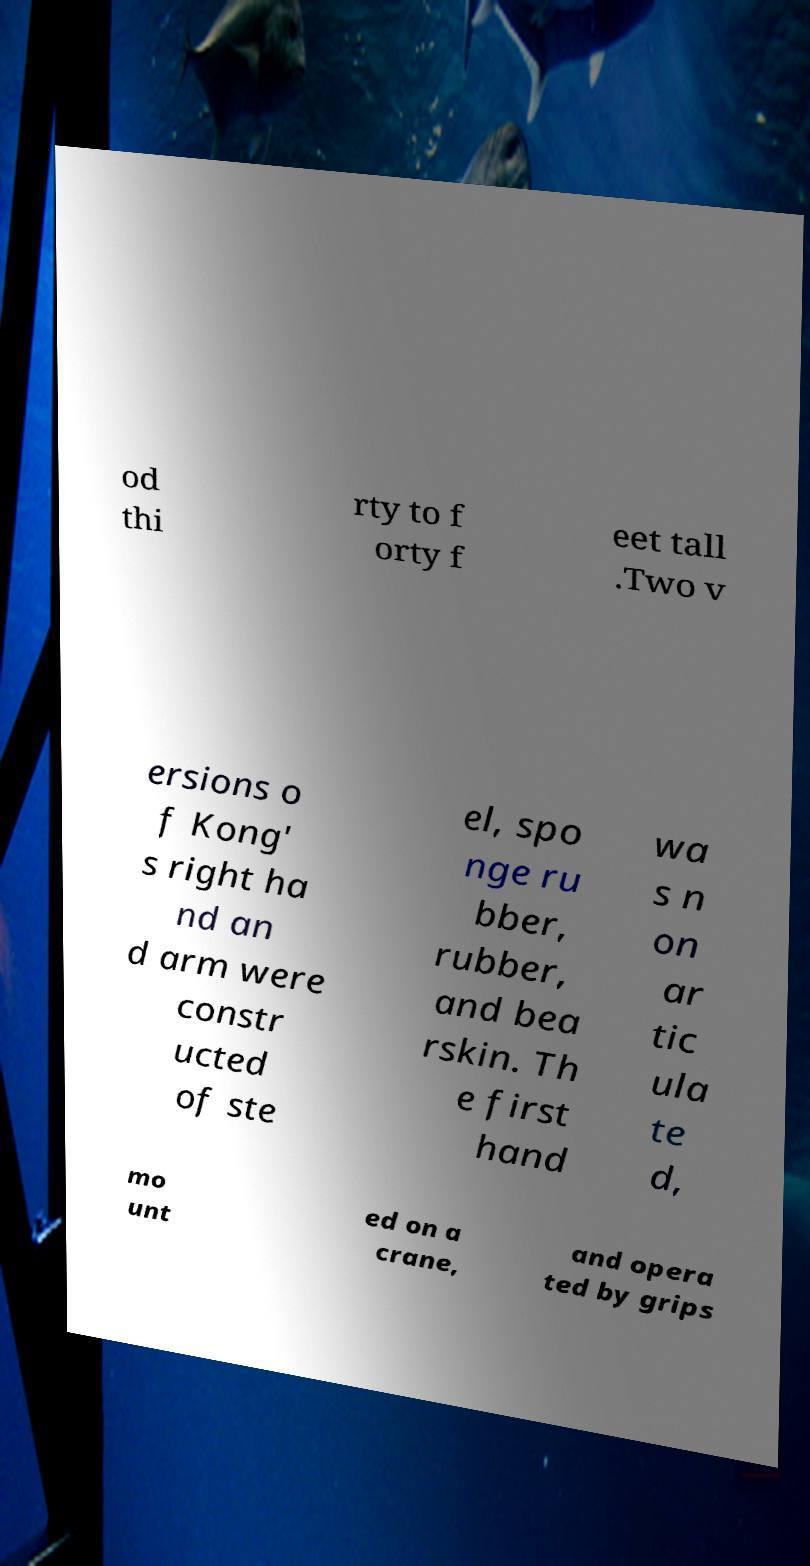I need the written content from this picture converted into text. Can you do that? od thi rty to f orty f eet tall .Two v ersions o f Kong' s right ha nd an d arm were constr ucted of ste el, spo nge ru bber, rubber, and bea rskin. Th e first hand wa s n on ar tic ula te d, mo unt ed on a crane, and opera ted by grips 